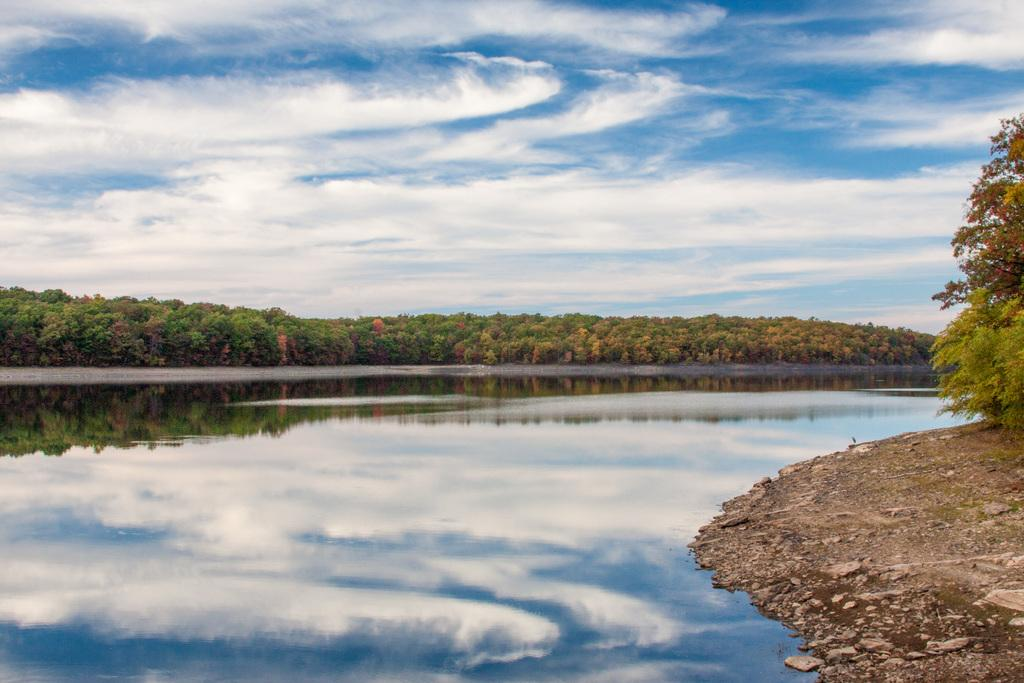What is the main feature in the center of the image? There is a lake in the center of the image. What can be seen in the background of the image? There are trees in the background of the image. What is visible in the sky at the top of the image? There are clouds visible in the sky at the top of the image. What type of scent can be smelled coming from the lake in the image? There is no indication of a scent in the image, as it is a visual representation. 